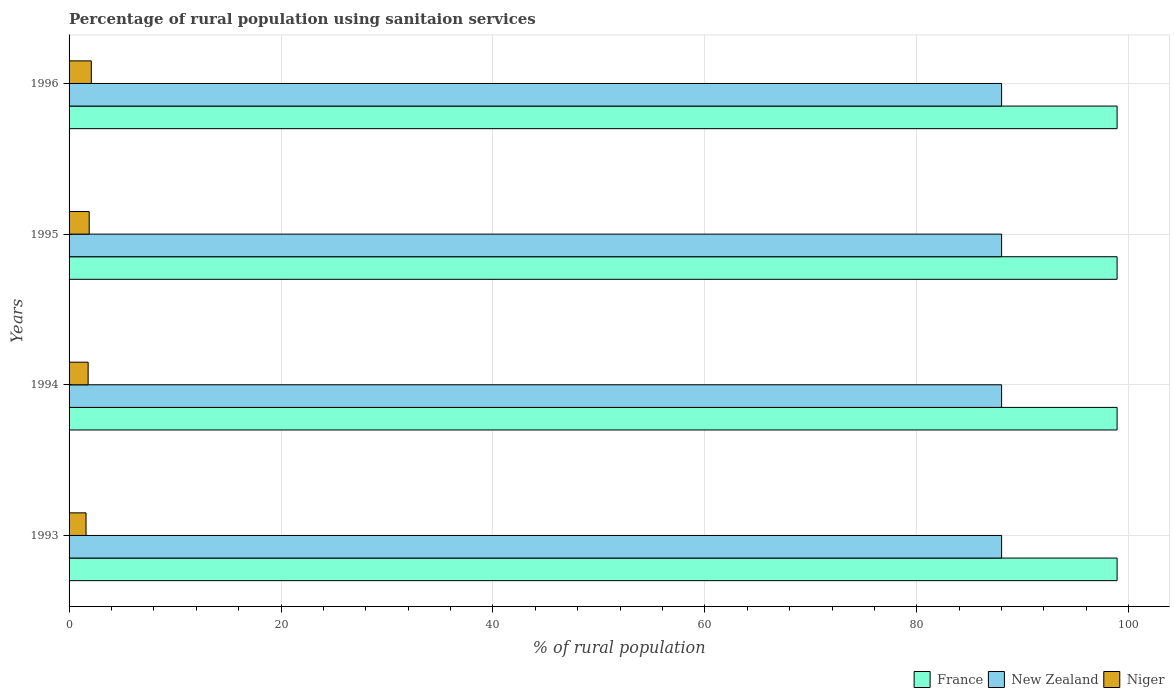How many different coloured bars are there?
Give a very brief answer. 3. How many groups of bars are there?
Your answer should be compact. 4. Are the number of bars per tick equal to the number of legend labels?
Ensure brevity in your answer.  Yes. Are the number of bars on each tick of the Y-axis equal?
Give a very brief answer. Yes. In how many cases, is the number of bars for a given year not equal to the number of legend labels?
Provide a short and direct response. 0. Across all years, what is the maximum percentage of rural population using sanitaion services in New Zealand?
Your answer should be compact. 88. Across all years, what is the minimum percentage of rural population using sanitaion services in New Zealand?
Keep it short and to the point. 88. What is the total percentage of rural population using sanitaion services in France in the graph?
Provide a succinct answer. 395.6. What is the difference between the percentage of rural population using sanitaion services in New Zealand in 1993 and the percentage of rural population using sanitaion services in France in 1995?
Keep it short and to the point. -10.9. What is the average percentage of rural population using sanitaion services in New Zealand per year?
Offer a terse response. 88. In the year 1995, what is the difference between the percentage of rural population using sanitaion services in Niger and percentage of rural population using sanitaion services in France?
Offer a very short reply. -97. In how many years, is the percentage of rural population using sanitaion services in New Zealand greater than 92 %?
Keep it short and to the point. 0. Is the percentage of rural population using sanitaion services in France in 1995 less than that in 1996?
Make the answer very short. No. Is the difference between the percentage of rural population using sanitaion services in Niger in 1993 and 1994 greater than the difference between the percentage of rural population using sanitaion services in France in 1993 and 1994?
Provide a succinct answer. No. What is the difference between the highest and the second highest percentage of rural population using sanitaion services in Niger?
Your answer should be compact. 0.2. What does the 2nd bar from the top in 1994 represents?
Ensure brevity in your answer.  New Zealand. What does the 3rd bar from the bottom in 1995 represents?
Provide a short and direct response. Niger. Is it the case that in every year, the sum of the percentage of rural population using sanitaion services in Niger and percentage of rural population using sanitaion services in New Zealand is greater than the percentage of rural population using sanitaion services in France?
Ensure brevity in your answer.  No. How many bars are there?
Your answer should be compact. 12. How many years are there in the graph?
Your response must be concise. 4. What is the difference between two consecutive major ticks on the X-axis?
Your answer should be compact. 20. Are the values on the major ticks of X-axis written in scientific E-notation?
Offer a very short reply. No. Does the graph contain grids?
Give a very brief answer. Yes. How many legend labels are there?
Provide a succinct answer. 3. How are the legend labels stacked?
Offer a terse response. Horizontal. What is the title of the graph?
Give a very brief answer. Percentage of rural population using sanitaion services. Does "Afghanistan" appear as one of the legend labels in the graph?
Give a very brief answer. No. What is the label or title of the X-axis?
Offer a terse response. % of rural population. What is the label or title of the Y-axis?
Give a very brief answer. Years. What is the % of rural population of France in 1993?
Your answer should be very brief. 98.9. What is the % of rural population in New Zealand in 1993?
Provide a succinct answer. 88. What is the % of rural population of France in 1994?
Your answer should be compact. 98.9. What is the % of rural population of New Zealand in 1994?
Keep it short and to the point. 88. What is the % of rural population in France in 1995?
Your response must be concise. 98.9. What is the % of rural population of New Zealand in 1995?
Provide a succinct answer. 88. What is the % of rural population of Niger in 1995?
Keep it short and to the point. 1.9. What is the % of rural population in France in 1996?
Your answer should be very brief. 98.9. What is the % of rural population in Niger in 1996?
Make the answer very short. 2.1. Across all years, what is the maximum % of rural population in France?
Provide a succinct answer. 98.9. Across all years, what is the maximum % of rural population in Niger?
Your answer should be compact. 2.1. Across all years, what is the minimum % of rural population of France?
Your answer should be very brief. 98.9. Across all years, what is the minimum % of rural population of New Zealand?
Offer a terse response. 88. Across all years, what is the minimum % of rural population in Niger?
Make the answer very short. 1.6. What is the total % of rural population of France in the graph?
Give a very brief answer. 395.6. What is the total % of rural population of New Zealand in the graph?
Offer a terse response. 352. What is the difference between the % of rural population of France in 1993 and that in 1994?
Your response must be concise. 0. What is the difference between the % of rural population in New Zealand in 1993 and that in 1994?
Your answer should be compact. 0. What is the difference between the % of rural population in Niger in 1993 and that in 1994?
Your response must be concise. -0.2. What is the difference between the % of rural population of New Zealand in 1993 and that in 1995?
Offer a terse response. 0. What is the difference between the % of rural population of New Zealand in 1993 and that in 1996?
Offer a terse response. 0. What is the difference between the % of rural population in France in 1994 and that in 1995?
Make the answer very short. 0. What is the difference between the % of rural population of New Zealand in 1994 and that in 1995?
Your answer should be very brief. 0. What is the difference between the % of rural population in France in 1994 and that in 1996?
Your answer should be compact. 0. What is the difference between the % of rural population in New Zealand in 1994 and that in 1996?
Provide a short and direct response. 0. What is the difference between the % of rural population in New Zealand in 1995 and that in 1996?
Your response must be concise. 0. What is the difference between the % of rural population of Niger in 1995 and that in 1996?
Make the answer very short. -0.2. What is the difference between the % of rural population in France in 1993 and the % of rural population in New Zealand in 1994?
Provide a short and direct response. 10.9. What is the difference between the % of rural population of France in 1993 and the % of rural population of Niger in 1994?
Make the answer very short. 97.1. What is the difference between the % of rural population of New Zealand in 1993 and the % of rural population of Niger in 1994?
Provide a succinct answer. 86.2. What is the difference between the % of rural population in France in 1993 and the % of rural population in Niger in 1995?
Your response must be concise. 97. What is the difference between the % of rural population in New Zealand in 1993 and the % of rural population in Niger in 1995?
Give a very brief answer. 86.1. What is the difference between the % of rural population in France in 1993 and the % of rural population in New Zealand in 1996?
Offer a terse response. 10.9. What is the difference between the % of rural population in France in 1993 and the % of rural population in Niger in 1996?
Provide a succinct answer. 96.8. What is the difference between the % of rural population of New Zealand in 1993 and the % of rural population of Niger in 1996?
Offer a terse response. 85.9. What is the difference between the % of rural population in France in 1994 and the % of rural population in Niger in 1995?
Provide a succinct answer. 97. What is the difference between the % of rural population of New Zealand in 1994 and the % of rural population of Niger in 1995?
Provide a short and direct response. 86.1. What is the difference between the % of rural population in France in 1994 and the % of rural population in Niger in 1996?
Give a very brief answer. 96.8. What is the difference between the % of rural population of New Zealand in 1994 and the % of rural population of Niger in 1996?
Offer a terse response. 85.9. What is the difference between the % of rural population of France in 1995 and the % of rural population of New Zealand in 1996?
Offer a very short reply. 10.9. What is the difference between the % of rural population in France in 1995 and the % of rural population in Niger in 1996?
Give a very brief answer. 96.8. What is the difference between the % of rural population of New Zealand in 1995 and the % of rural population of Niger in 1996?
Your response must be concise. 85.9. What is the average % of rural population in France per year?
Your response must be concise. 98.9. What is the average % of rural population of Niger per year?
Your answer should be compact. 1.85. In the year 1993, what is the difference between the % of rural population of France and % of rural population of New Zealand?
Your response must be concise. 10.9. In the year 1993, what is the difference between the % of rural population of France and % of rural population of Niger?
Your answer should be compact. 97.3. In the year 1993, what is the difference between the % of rural population in New Zealand and % of rural population in Niger?
Your response must be concise. 86.4. In the year 1994, what is the difference between the % of rural population in France and % of rural population in Niger?
Make the answer very short. 97.1. In the year 1994, what is the difference between the % of rural population of New Zealand and % of rural population of Niger?
Your answer should be very brief. 86.2. In the year 1995, what is the difference between the % of rural population of France and % of rural population of Niger?
Ensure brevity in your answer.  97. In the year 1995, what is the difference between the % of rural population in New Zealand and % of rural population in Niger?
Your answer should be compact. 86.1. In the year 1996, what is the difference between the % of rural population in France and % of rural population in Niger?
Keep it short and to the point. 96.8. In the year 1996, what is the difference between the % of rural population in New Zealand and % of rural population in Niger?
Offer a terse response. 85.9. What is the ratio of the % of rural population of Niger in 1993 to that in 1994?
Your response must be concise. 0.89. What is the ratio of the % of rural population in France in 1993 to that in 1995?
Offer a very short reply. 1. What is the ratio of the % of rural population of New Zealand in 1993 to that in 1995?
Ensure brevity in your answer.  1. What is the ratio of the % of rural population of Niger in 1993 to that in 1995?
Keep it short and to the point. 0.84. What is the ratio of the % of rural population of France in 1993 to that in 1996?
Your response must be concise. 1. What is the ratio of the % of rural population of New Zealand in 1993 to that in 1996?
Your answer should be compact. 1. What is the ratio of the % of rural population of Niger in 1993 to that in 1996?
Make the answer very short. 0.76. What is the ratio of the % of rural population of France in 1994 to that in 1995?
Your response must be concise. 1. What is the ratio of the % of rural population in New Zealand in 1994 to that in 1995?
Ensure brevity in your answer.  1. What is the ratio of the % of rural population in New Zealand in 1994 to that in 1996?
Your answer should be compact. 1. What is the ratio of the % of rural population in Niger in 1994 to that in 1996?
Your answer should be compact. 0.86. What is the ratio of the % of rural population of France in 1995 to that in 1996?
Keep it short and to the point. 1. What is the ratio of the % of rural population in Niger in 1995 to that in 1996?
Give a very brief answer. 0.9. What is the difference between the highest and the lowest % of rural population in France?
Ensure brevity in your answer.  0. What is the difference between the highest and the lowest % of rural population of New Zealand?
Ensure brevity in your answer.  0. 